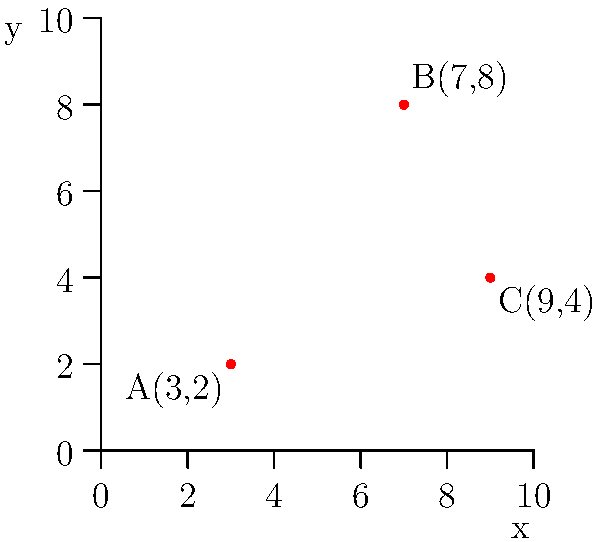Given three potential locations for cybersecurity defense systems on a 2D grid: A(3,2), B(7,8), and C(9,4), determine the coordinates of the point that minimizes the sum of distances to all three locations. This optimal point will serve as the central command for coordinating cyber threat responses. Round your answer to the nearest integer coordinates. To find the optimal point that minimizes the sum of distances to all three given points, we need to follow these steps:

1. Calculate the centroid of the triangle formed by the three points. The centroid represents the arithmetic mean position of all points and is a good approximation for the optimal location.

2. The formula for the centroid (x,y) is:
   $$x = \frac{x_1 + x_2 + x_3}{3}, y = \frac{y_1 + y_2 + y_3}{3}$$
   where $(x_1,y_1)$, $(x_2,y_2)$, and $(x_3,y_3)$ are the coordinates of the three points.

3. Substituting the given coordinates:
   $$x = \frac{3 + 7 + 9}{3} = \frac{19}{3} \approx 6.33$$
   $$y = \frac{2 + 8 + 4}{3} = \frac{14}{3} \approx 4.67$$

4. Rounding to the nearest integer coordinates:
   $x = 6$, $y = 5$

Therefore, the optimal location for the central command, minimizing the sum of distances to all three cybersecurity defense systems, is approximately at the point (6,5).
Answer: (6,5) 